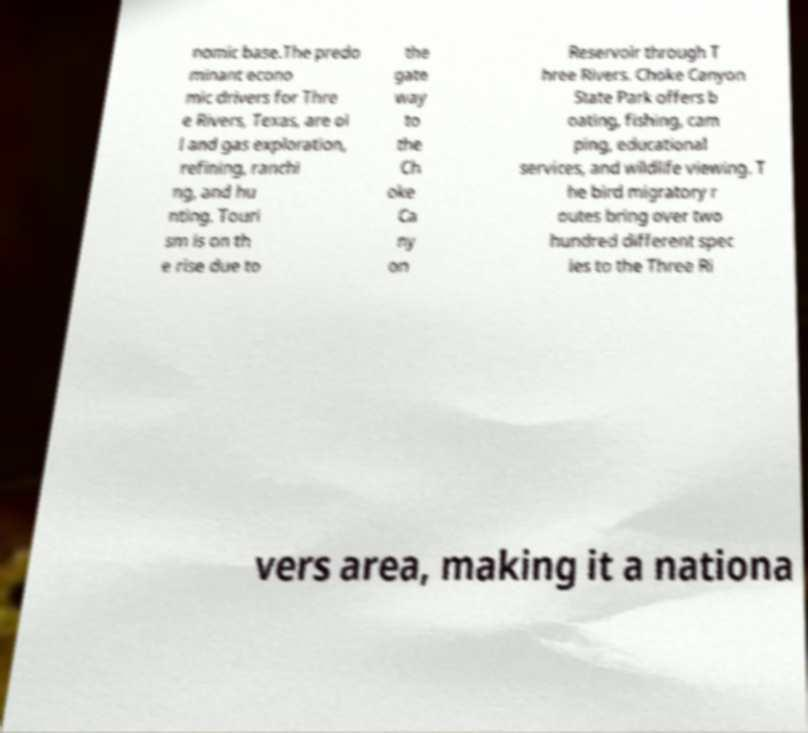What messages or text are displayed in this image? I need them in a readable, typed format. nomic base.The predo minant econo mic drivers for Thre e Rivers, Texas, are oi l and gas exploration, refining, ranchi ng, and hu nting. Touri sm is on th e rise due to the gate way to the Ch oke Ca ny on Reservoir through T hree Rivers. Choke Canyon State Park offers b oating, fishing, cam ping, educational services, and wildlife viewing. T he bird migratory r outes bring over two hundred different spec ies to the Three Ri vers area, making it a nationa 